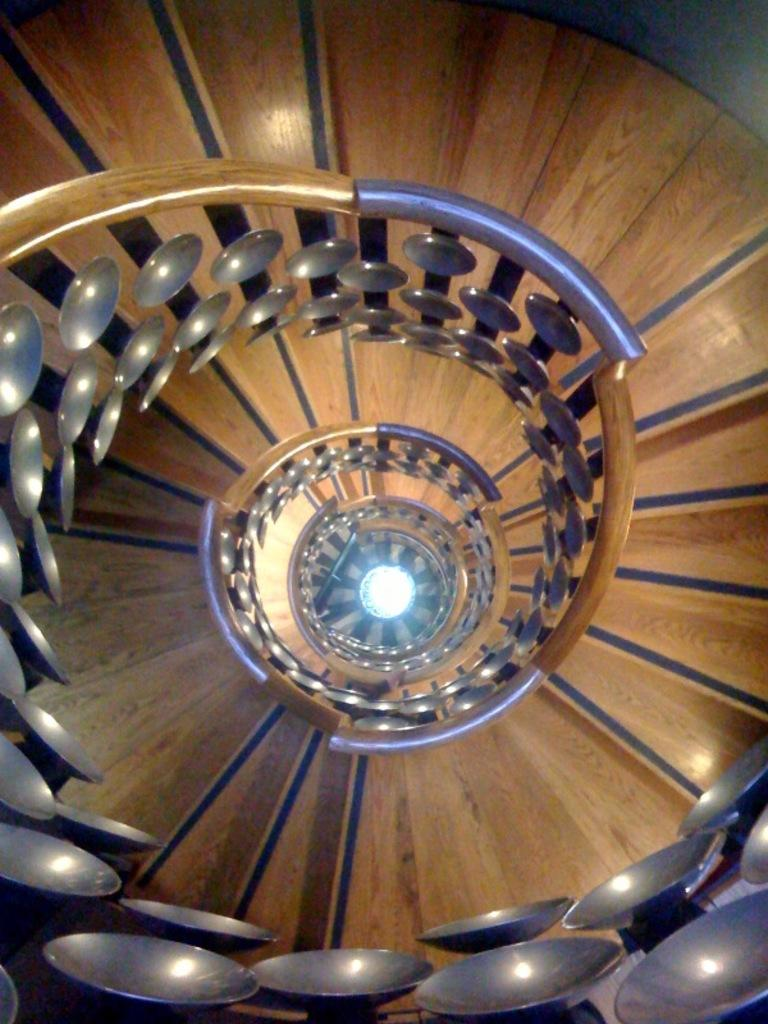What type of staircase is visible in the image? There is a wooden staircase in the image. Can you describe the lighting in the image? There is a light in the image. What type of bun is being held by the lawyer in the image? There is no lawyer or bun present in the image. 